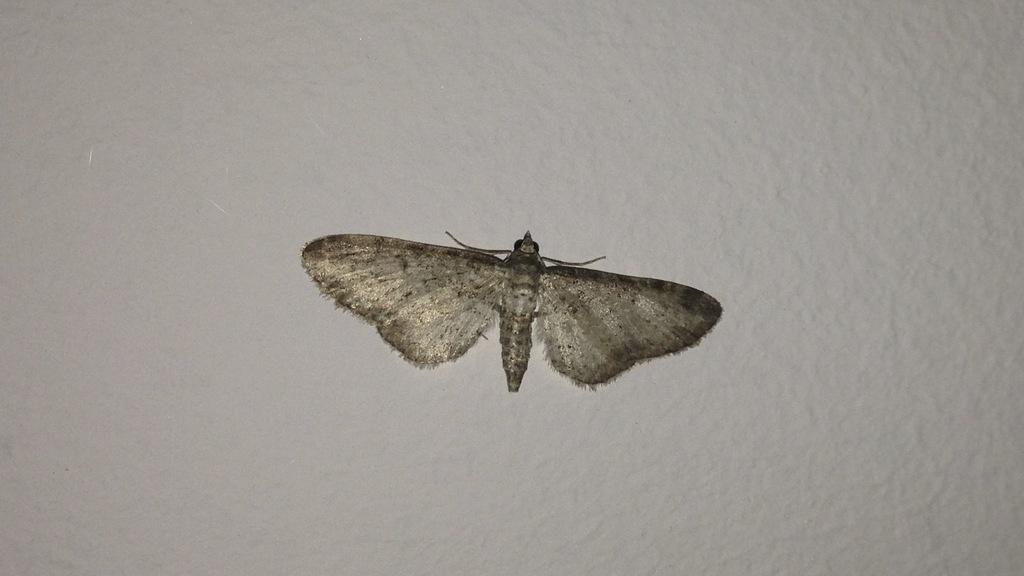What type of creature is present in the image? There is an insect in the image. What colors can be seen on the insect? The insect has brown and gray colors. What is the color of the background in the image? The background of the image is white. Is there a comfortable sofa in the image for the insect to rest on? There is no sofa present in the image, and the insect's comfort is not relevant to the image's content. 